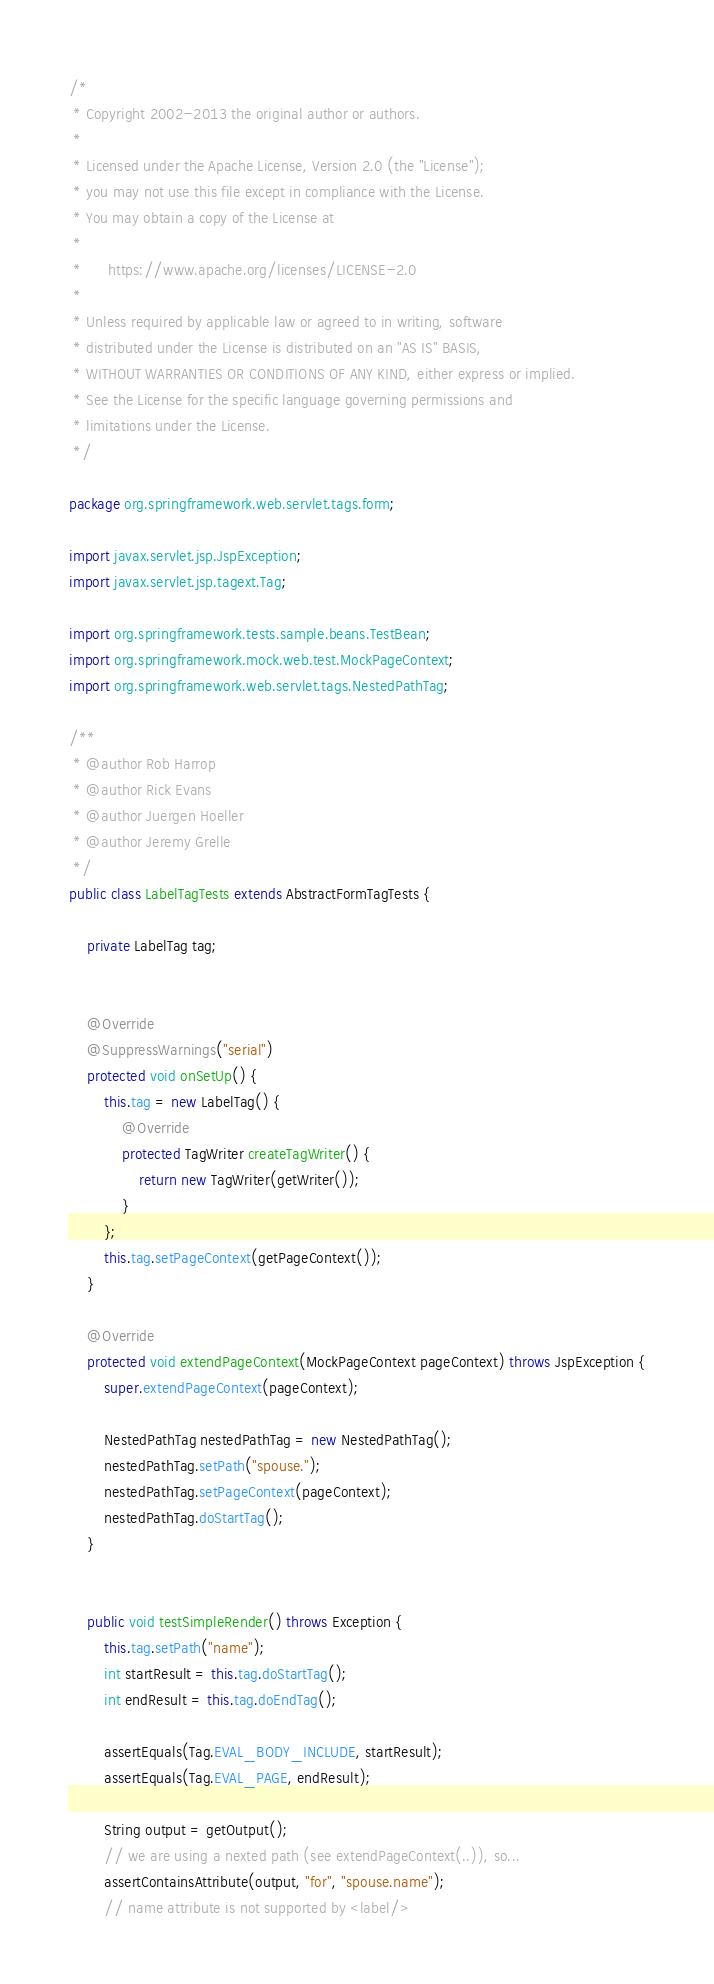Convert code to text. <code><loc_0><loc_0><loc_500><loc_500><_Java_>/*
 * Copyright 2002-2013 the original author or authors.
 *
 * Licensed under the Apache License, Version 2.0 (the "License");
 * you may not use this file except in compliance with the License.
 * You may obtain a copy of the License at
 *
 *      https://www.apache.org/licenses/LICENSE-2.0
 *
 * Unless required by applicable law or agreed to in writing, software
 * distributed under the License is distributed on an "AS IS" BASIS,
 * WITHOUT WARRANTIES OR CONDITIONS OF ANY KIND, either express or implied.
 * See the License for the specific language governing permissions and
 * limitations under the License.
 */

package org.springframework.web.servlet.tags.form;

import javax.servlet.jsp.JspException;
import javax.servlet.jsp.tagext.Tag;

import org.springframework.tests.sample.beans.TestBean;
import org.springframework.mock.web.test.MockPageContext;
import org.springframework.web.servlet.tags.NestedPathTag;

/**
 * @author Rob Harrop
 * @author Rick Evans
 * @author Juergen Hoeller
 * @author Jeremy Grelle
 */
public class LabelTagTests extends AbstractFormTagTests {

	private LabelTag tag;


	@Override
	@SuppressWarnings("serial")
	protected void onSetUp() {
		this.tag = new LabelTag() {
			@Override
			protected TagWriter createTagWriter() {
				return new TagWriter(getWriter());
			}
		};
		this.tag.setPageContext(getPageContext());
	}

	@Override
	protected void extendPageContext(MockPageContext pageContext) throws JspException {
		super.extendPageContext(pageContext);

		NestedPathTag nestedPathTag = new NestedPathTag();
		nestedPathTag.setPath("spouse.");
		nestedPathTag.setPageContext(pageContext);
		nestedPathTag.doStartTag();
	}


	public void testSimpleRender() throws Exception {
		this.tag.setPath("name");
		int startResult = this.tag.doStartTag();
		int endResult = this.tag.doEndTag();

		assertEquals(Tag.EVAL_BODY_INCLUDE, startResult);
		assertEquals(Tag.EVAL_PAGE, endResult);

		String output = getOutput();
		// we are using a nexted path (see extendPageContext(..)), so...
		assertContainsAttribute(output, "for", "spouse.name");
		// name attribute is not supported by <label/></code> 